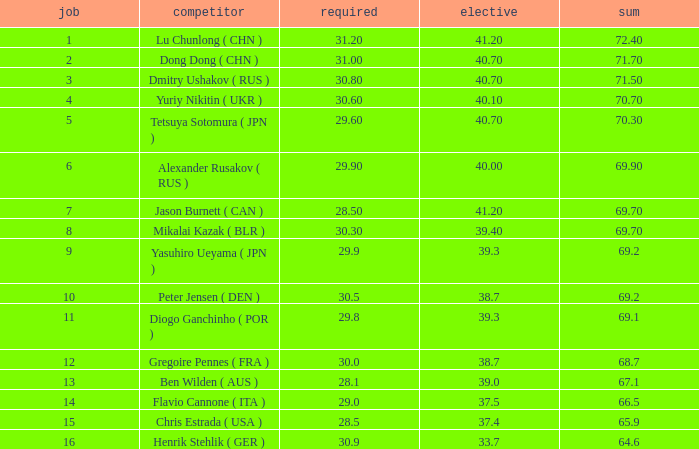What's the position that has a total less than 66.5m, a compulsory of 30.9 and voluntary less than 33.7? None. 